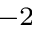Convert formula to latex. <formula><loc_0><loc_0><loc_500><loc_500>^ { - 2 }</formula> 